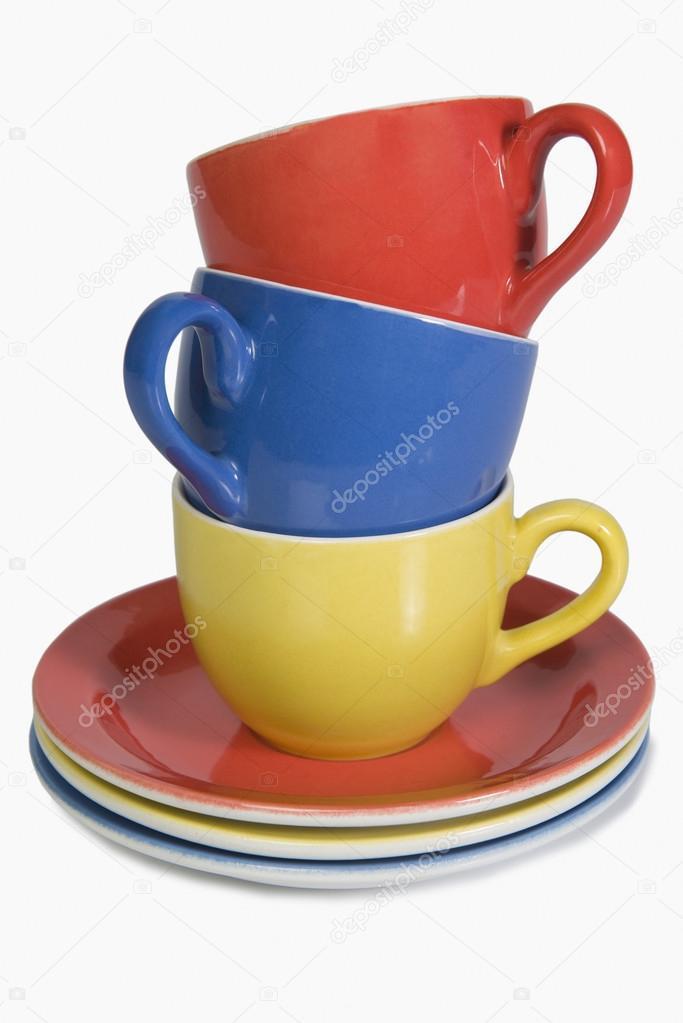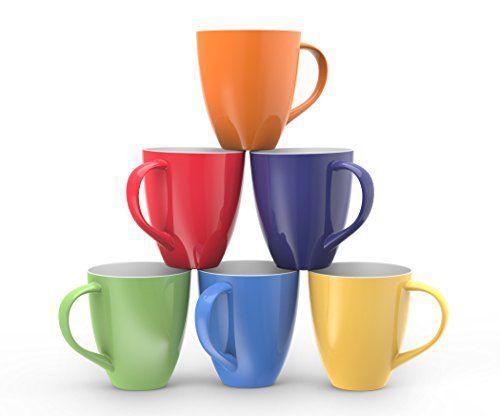The first image is the image on the left, the second image is the image on the right. For the images shown, is this caption "At least 4 cups are each placed on top of matching colored plates." true? Answer yes or no. No. 